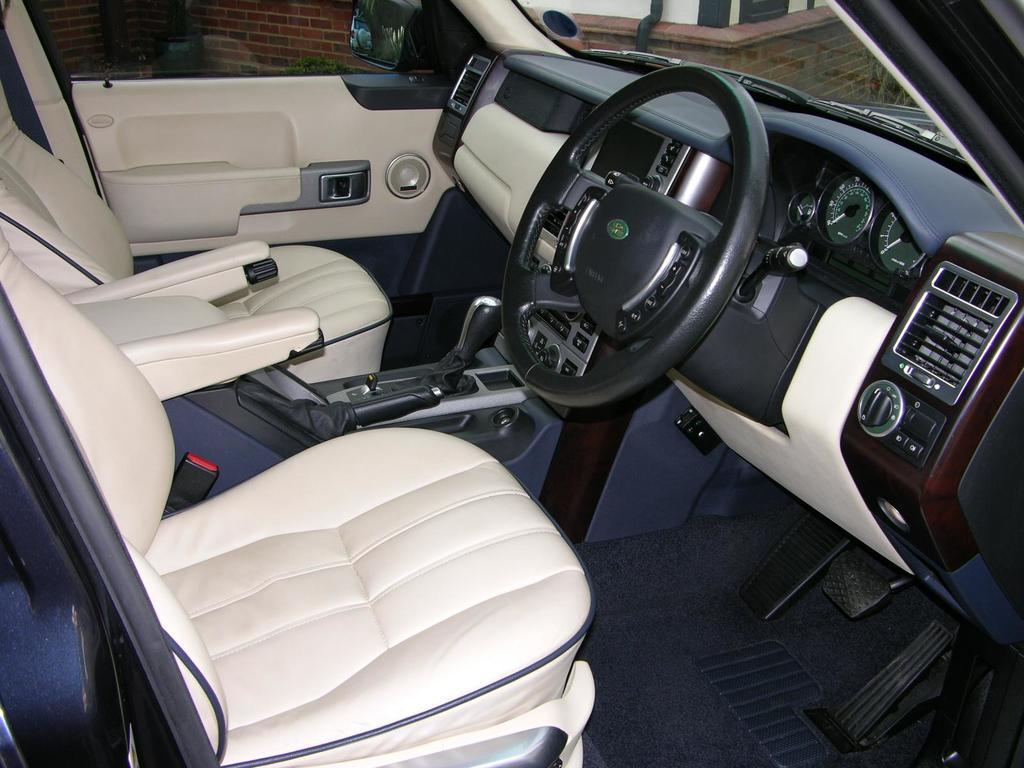What type of space is shown in the image? The image is of the inside part of a vehicle. What can be found inside the vehicle? There are seats and a steering wheel in the vehicle. How do the chickens react to the alarm in the image? There are no chickens or alarms present in the image; it shows the inside of a vehicle with seats and a steering wheel. 